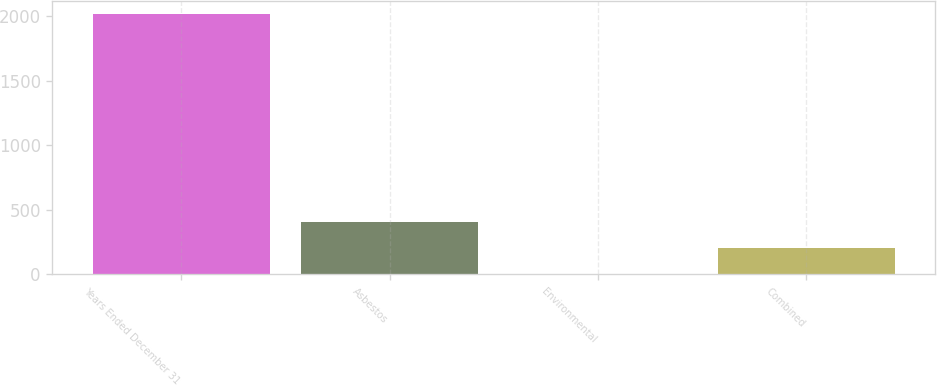Convert chart. <chart><loc_0><loc_0><loc_500><loc_500><bar_chart><fcel>Years Ended December 31<fcel>Asbestos<fcel>Environmental<fcel>Combined<nl><fcel>2012<fcel>405.92<fcel>4.4<fcel>205.16<nl></chart> 